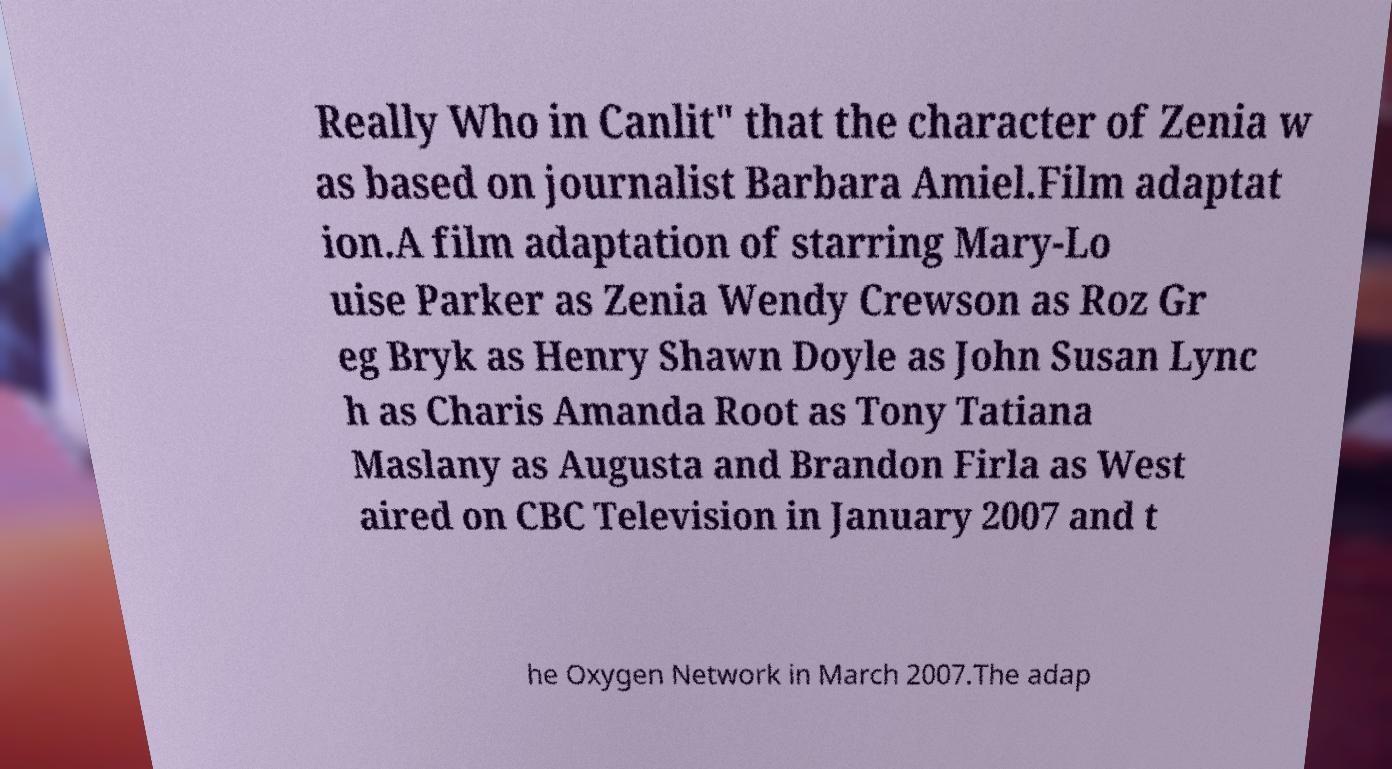For documentation purposes, I need the text within this image transcribed. Could you provide that? Really Who in Canlit" that the character of Zenia w as based on journalist Barbara Amiel.Film adaptat ion.A film adaptation of starring Mary-Lo uise Parker as Zenia Wendy Crewson as Roz Gr eg Bryk as Henry Shawn Doyle as John Susan Lync h as Charis Amanda Root as Tony Tatiana Maslany as Augusta and Brandon Firla as West aired on CBC Television in January 2007 and t he Oxygen Network in March 2007.The adap 